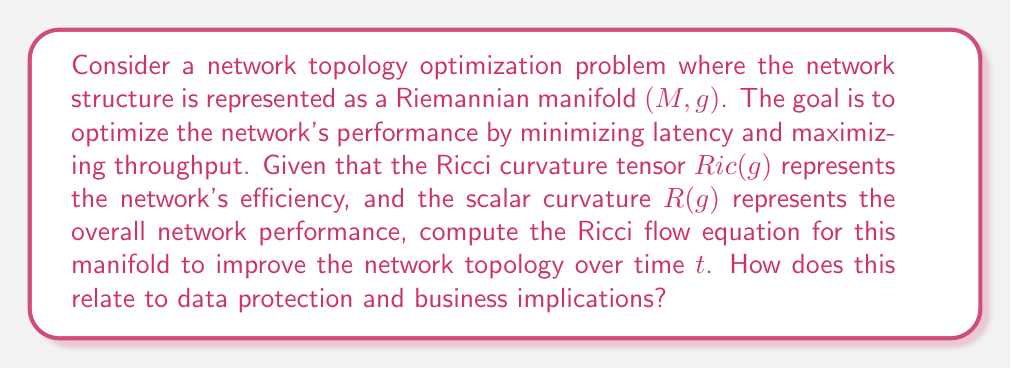Help me with this question. To solve this problem, we need to understand the Ricci flow equation and its application to network topology optimization:

1. The Ricci flow equation is given by:

   $$\frac{\partial g}{\partial t} = -2Ric(g)$$

   Where $g$ is the metric tensor and $t$ is time.

2. In the context of network topology, we can interpret this equation as follows:
   - Areas of high positive curvature (efficient connections) will tend to shrink
   - Areas of negative curvature (bottlenecks) will tend to expand

3. To relate this to data protection and business implications, we need to consider how the network topology affects data security and business operations:
   - Efficient connections (high positive curvature) may represent secure, high-bandwidth links
   - Bottlenecks (negative curvature) may represent vulnerable or congested network segments

4. As the Ricci flow progresses, it will:
   - Improve overall network efficiency by reducing bottlenecks
   - Potentially identify areas where additional security measures are needed
   - Optimize the distribution of network resources

5. The scalar curvature $R(g)$ can be used as a metric for overall network performance:

   $$R(g) = g^{ij}Ric_{ij}$$

   Where $g^{ij}$ is the inverse metric tensor and $Ric_{ij}$ are the components of the Ricci tensor.

6. By monitoring $R(g)$ over time, IT managers can assess the impact of topology changes on network performance and security.

7. The business implications of this optimization include:
   - Improved data protection through better network structure
   - Enhanced performance leading to increased productivity
   - Potential cost savings by identifying and eliminating inefficient network segments
Answer: The Ricci flow equation for the network topology optimization manifold is:

$$\frac{\partial g}{\partial t} = -2Ric(g)$$

This equation describes how the network topology should evolve over time to optimize performance and security. For IT managers, this mathematical model provides a framework for continuous network improvement, balancing efficiency with data protection needs. By monitoring the scalar curvature $R(g)$, managers can quantify the overall impact of these changes on network performance and security, enabling data-driven decisions in network infrastructure management. 